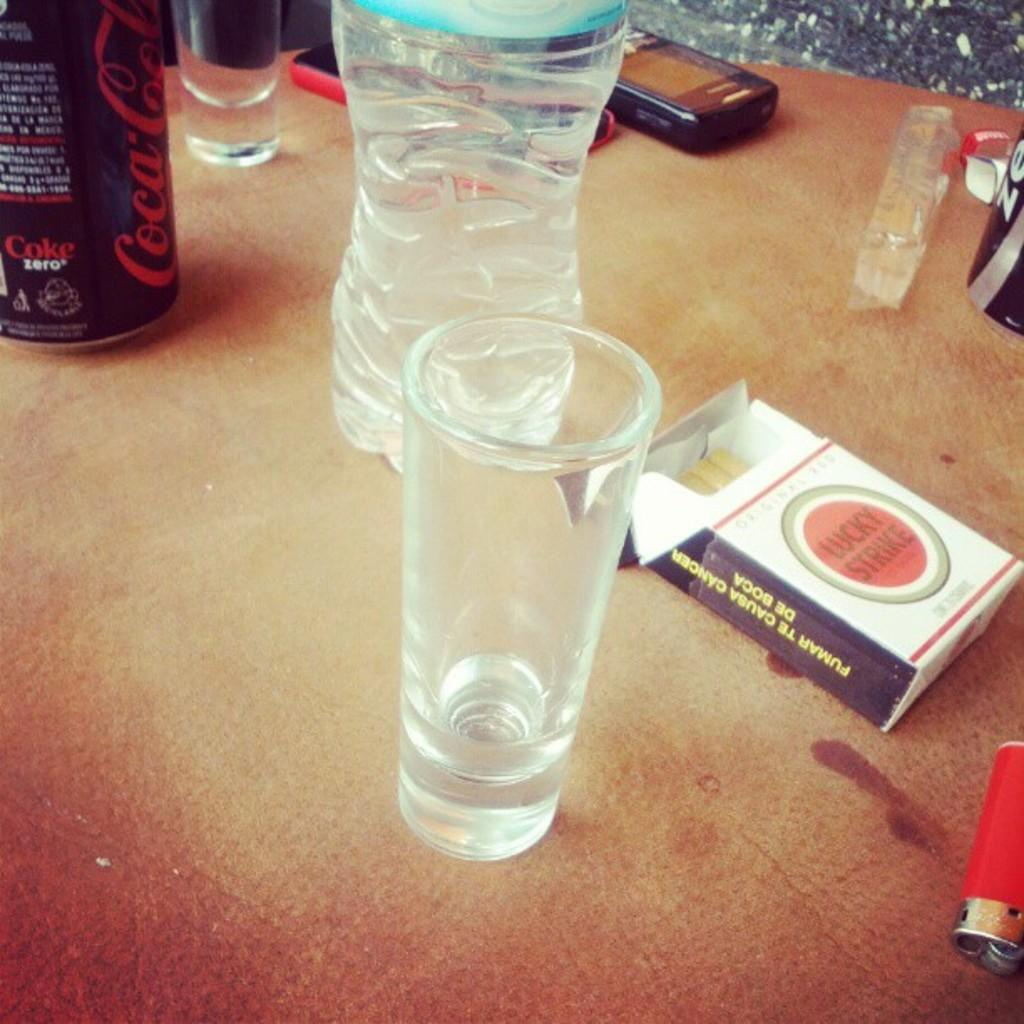<image>
Give a short and clear explanation of the subsequent image. A package of open Lucky Strike cigarettes next to a water bottle. 